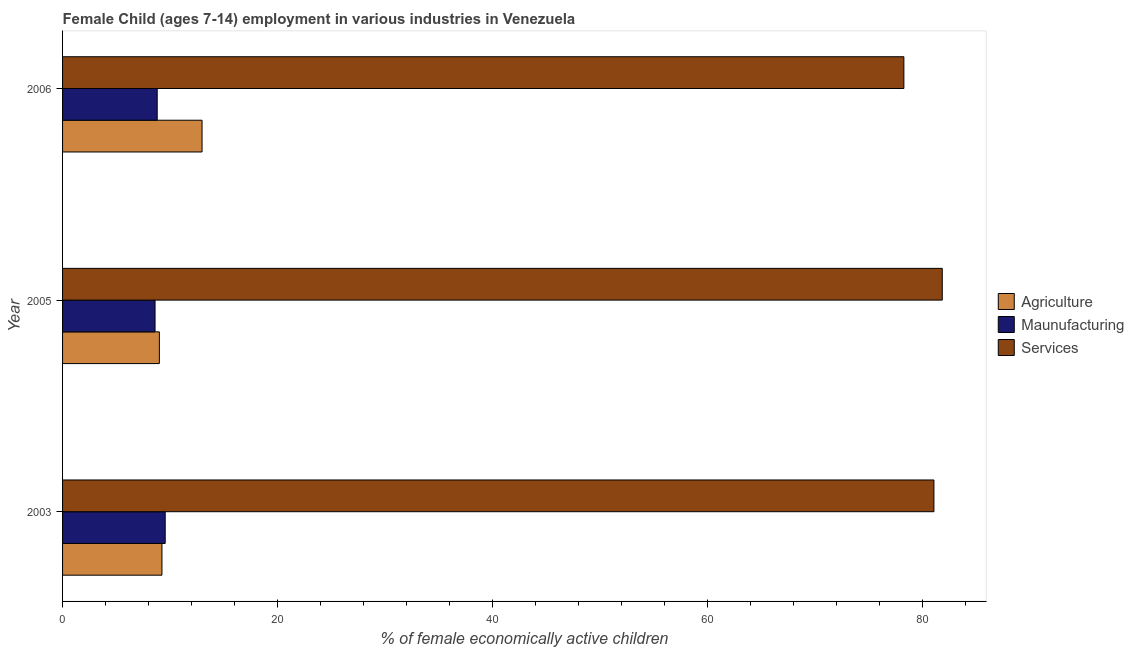How many different coloured bars are there?
Ensure brevity in your answer.  3. How many bars are there on the 3rd tick from the bottom?
Provide a short and direct response. 3. What is the label of the 2nd group of bars from the top?
Your response must be concise. 2005. In how many cases, is the number of bars for a given year not equal to the number of legend labels?
Give a very brief answer. 0. What is the percentage of economically active children in services in 2006?
Provide a succinct answer. 78.23. Across all years, what is the maximum percentage of economically active children in manufacturing?
Make the answer very short. 9.54. In which year was the percentage of economically active children in manufacturing maximum?
Give a very brief answer. 2003. What is the total percentage of economically active children in agriculture in the graph?
Your response must be concise. 31.21. What is the difference between the percentage of economically active children in agriculture in 2003 and that in 2006?
Keep it short and to the point. -3.73. What is the difference between the percentage of economically active children in agriculture in 2006 and the percentage of economically active children in services in 2003?
Keep it short and to the point. -68.05. What is the average percentage of economically active children in agriculture per year?
Make the answer very short. 10.4. In the year 2006, what is the difference between the percentage of economically active children in manufacturing and percentage of economically active children in services?
Offer a very short reply. -69.43. What is the ratio of the percentage of economically active children in manufacturing in 2003 to that in 2006?
Your answer should be compact. 1.08. Is the percentage of economically active children in manufacturing in 2005 less than that in 2006?
Your answer should be very brief. Yes. What is the difference between the highest and the second highest percentage of economically active children in manufacturing?
Offer a terse response. 0.74. What is the difference between the highest and the lowest percentage of economically active children in agriculture?
Your response must be concise. 3.97. What does the 2nd bar from the top in 2005 represents?
Offer a terse response. Maunufacturing. What does the 3rd bar from the bottom in 2005 represents?
Make the answer very short. Services. Are all the bars in the graph horizontal?
Offer a terse response. Yes. How many years are there in the graph?
Your response must be concise. 3. What is the difference between two consecutive major ticks on the X-axis?
Offer a terse response. 20. Does the graph contain any zero values?
Offer a terse response. No. Where does the legend appear in the graph?
Make the answer very short. Center right. What is the title of the graph?
Offer a terse response. Female Child (ages 7-14) employment in various industries in Venezuela. Does "Manufactures" appear as one of the legend labels in the graph?
Provide a short and direct response. No. What is the label or title of the X-axis?
Your answer should be very brief. % of female economically active children. What is the % of female economically active children of Agriculture in 2003?
Provide a succinct answer. 9.24. What is the % of female economically active children of Maunufacturing in 2003?
Your answer should be compact. 9.54. What is the % of female economically active children of Services in 2003?
Provide a succinct answer. 81.02. What is the % of female economically active children in Services in 2005?
Give a very brief answer. 81.8. What is the % of female economically active children of Agriculture in 2006?
Give a very brief answer. 12.97. What is the % of female economically active children in Services in 2006?
Ensure brevity in your answer.  78.23. Across all years, what is the maximum % of female economically active children of Agriculture?
Offer a very short reply. 12.97. Across all years, what is the maximum % of female economically active children in Maunufacturing?
Make the answer very short. 9.54. Across all years, what is the maximum % of female economically active children of Services?
Offer a very short reply. 81.8. Across all years, what is the minimum % of female economically active children of Agriculture?
Make the answer very short. 9. Across all years, what is the minimum % of female economically active children in Maunufacturing?
Give a very brief answer. 8.6. Across all years, what is the minimum % of female economically active children in Services?
Your answer should be compact. 78.23. What is the total % of female economically active children in Agriculture in the graph?
Offer a very short reply. 31.21. What is the total % of female economically active children in Maunufacturing in the graph?
Keep it short and to the point. 26.94. What is the total % of female economically active children of Services in the graph?
Give a very brief answer. 241.05. What is the difference between the % of female economically active children of Agriculture in 2003 and that in 2005?
Provide a short and direct response. 0.24. What is the difference between the % of female economically active children in Maunufacturing in 2003 and that in 2005?
Give a very brief answer. 0.94. What is the difference between the % of female economically active children in Services in 2003 and that in 2005?
Give a very brief answer. -0.78. What is the difference between the % of female economically active children in Agriculture in 2003 and that in 2006?
Provide a succinct answer. -3.73. What is the difference between the % of female economically active children in Maunufacturing in 2003 and that in 2006?
Make the answer very short. 0.74. What is the difference between the % of female economically active children of Services in 2003 and that in 2006?
Your answer should be very brief. 2.79. What is the difference between the % of female economically active children in Agriculture in 2005 and that in 2006?
Keep it short and to the point. -3.97. What is the difference between the % of female economically active children of Maunufacturing in 2005 and that in 2006?
Keep it short and to the point. -0.2. What is the difference between the % of female economically active children of Services in 2005 and that in 2006?
Your answer should be very brief. 3.57. What is the difference between the % of female economically active children in Agriculture in 2003 and the % of female economically active children in Maunufacturing in 2005?
Make the answer very short. 0.64. What is the difference between the % of female economically active children of Agriculture in 2003 and the % of female economically active children of Services in 2005?
Ensure brevity in your answer.  -72.56. What is the difference between the % of female economically active children in Maunufacturing in 2003 and the % of female economically active children in Services in 2005?
Offer a terse response. -72.26. What is the difference between the % of female economically active children of Agriculture in 2003 and the % of female economically active children of Maunufacturing in 2006?
Keep it short and to the point. 0.44. What is the difference between the % of female economically active children in Agriculture in 2003 and the % of female economically active children in Services in 2006?
Make the answer very short. -68.99. What is the difference between the % of female economically active children of Maunufacturing in 2003 and the % of female economically active children of Services in 2006?
Your answer should be very brief. -68.69. What is the difference between the % of female economically active children of Agriculture in 2005 and the % of female economically active children of Services in 2006?
Offer a very short reply. -69.23. What is the difference between the % of female economically active children in Maunufacturing in 2005 and the % of female economically active children in Services in 2006?
Give a very brief answer. -69.63. What is the average % of female economically active children in Agriculture per year?
Make the answer very short. 10.4. What is the average % of female economically active children of Maunufacturing per year?
Ensure brevity in your answer.  8.98. What is the average % of female economically active children of Services per year?
Give a very brief answer. 80.35. In the year 2003, what is the difference between the % of female economically active children of Agriculture and % of female economically active children of Maunufacturing?
Your answer should be compact. -0.3. In the year 2003, what is the difference between the % of female economically active children in Agriculture and % of female economically active children in Services?
Provide a succinct answer. -71.78. In the year 2003, what is the difference between the % of female economically active children of Maunufacturing and % of female economically active children of Services?
Your response must be concise. -71.48. In the year 2005, what is the difference between the % of female economically active children of Agriculture and % of female economically active children of Maunufacturing?
Ensure brevity in your answer.  0.4. In the year 2005, what is the difference between the % of female economically active children of Agriculture and % of female economically active children of Services?
Offer a very short reply. -72.8. In the year 2005, what is the difference between the % of female economically active children in Maunufacturing and % of female economically active children in Services?
Your answer should be compact. -73.2. In the year 2006, what is the difference between the % of female economically active children in Agriculture and % of female economically active children in Maunufacturing?
Offer a terse response. 4.17. In the year 2006, what is the difference between the % of female economically active children of Agriculture and % of female economically active children of Services?
Offer a terse response. -65.26. In the year 2006, what is the difference between the % of female economically active children in Maunufacturing and % of female economically active children in Services?
Give a very brief answer. -69.43. What is the ratio of the % of female economically active children of Agriculture in 2003 to that in 2005?
Offer a very short reply. 1.03. What is the ratio of the % of female economically active children of Maunufacturing in 2003 to that in 2005?
Your answer should be compact. 1.11. What is the ratio of the % of female economically active children in Services in 2003 to that in 2005?
Your answer should be compact. 0.99. What is the ratio of the % of female economically active children in Agriculture in 2003 to that in 2006?
Provide a succinct answer. 0.71. What is the ratio of the % of female economically active children in Maunufacturing in 2003 to that in 2006?
Ensure brevity in your answer.  1.08. What is the ratio of the % of female economically active children of Services in 2003 to that in 2006?
Provide a short and direct response. 1.04. What is the ratio of the % of female economically active children of Agriculture in 2005 to that in 2006?
Give a very brief answer. 0.69. What is the ratio of the % of female economically active children of Maunufacturing in 2005 to that in 2006?
Your answer should be compact. 0.98. What is the ratio of the % of female economically active children of Services in 2005 to that in 2006?
Give a very brief answer. 1.05. What is the difference between the highest and the second highest % of female economically active children of Agriculture?
Provide a short and direct response. 3.73. What is the difference between the highest and the second highest % of female economically active children in Maunufacturing?
Your response must be concise. 0.74. What is the difference between the highest and the second highest % of female economically active children in Services?
Your answer should be compact. 0.78. What is the difference between the highest and the lowest % of female economically active children in Agriculture?
Your answer should be compact. 3.97. What is the difference between the highest and the lowest % of female economically active children of Maunufacturing?
Your answer should be very brief. 0.94. What is the difference between the highest and the lowest % of female economically active children in Services?
Make the answer very short. 3.57. 